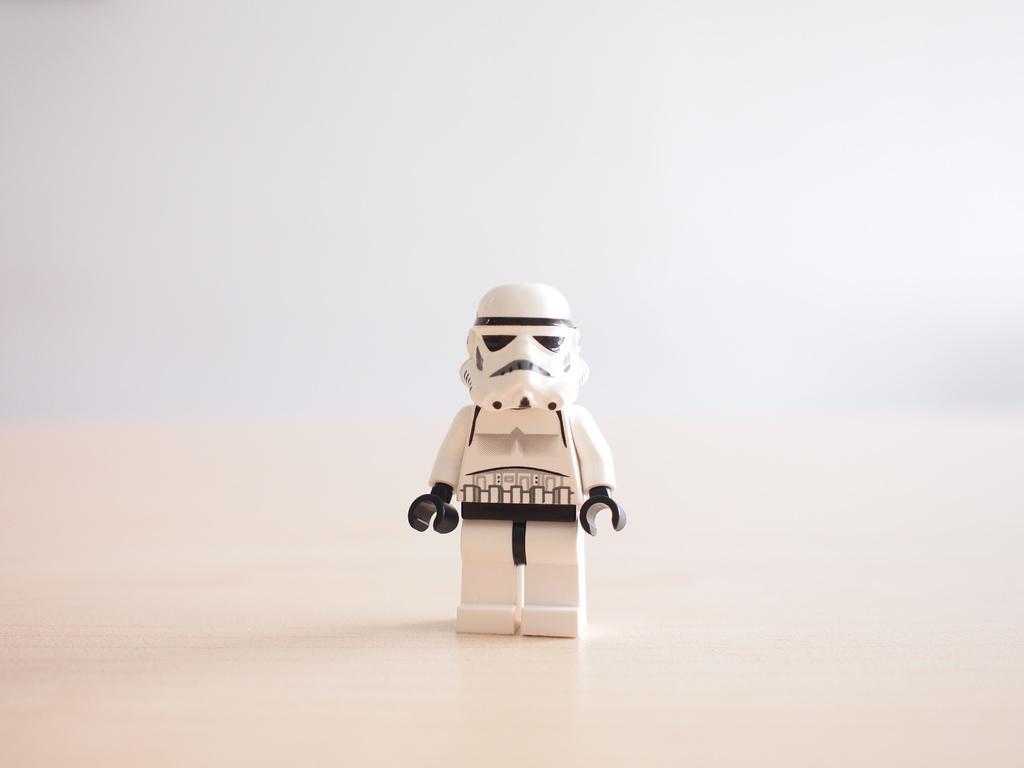Please provide a concise description of this image. In this image we can see a toy on the surface, and the background is white in color. 